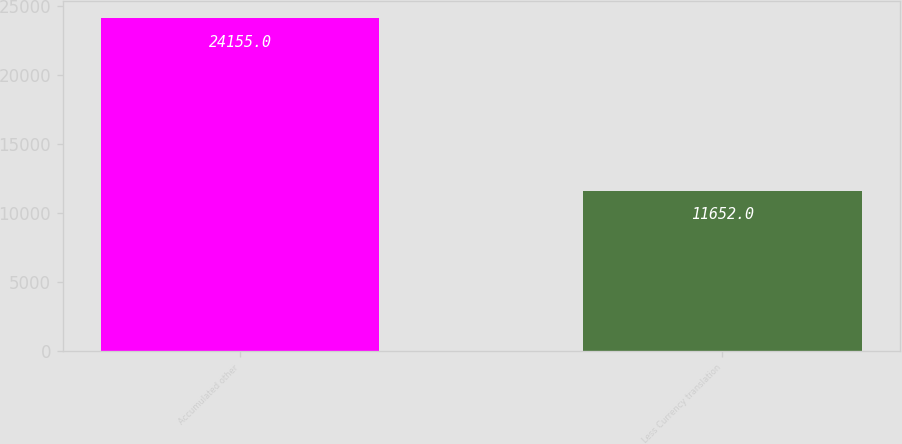<chart> <loc_0><loc_0><loc_500><loc_500><bar_chart><fcel>Accumulated other<fcel>Less Currency translation<nl><fcel>24155<fcel>11652<nl></chart> 